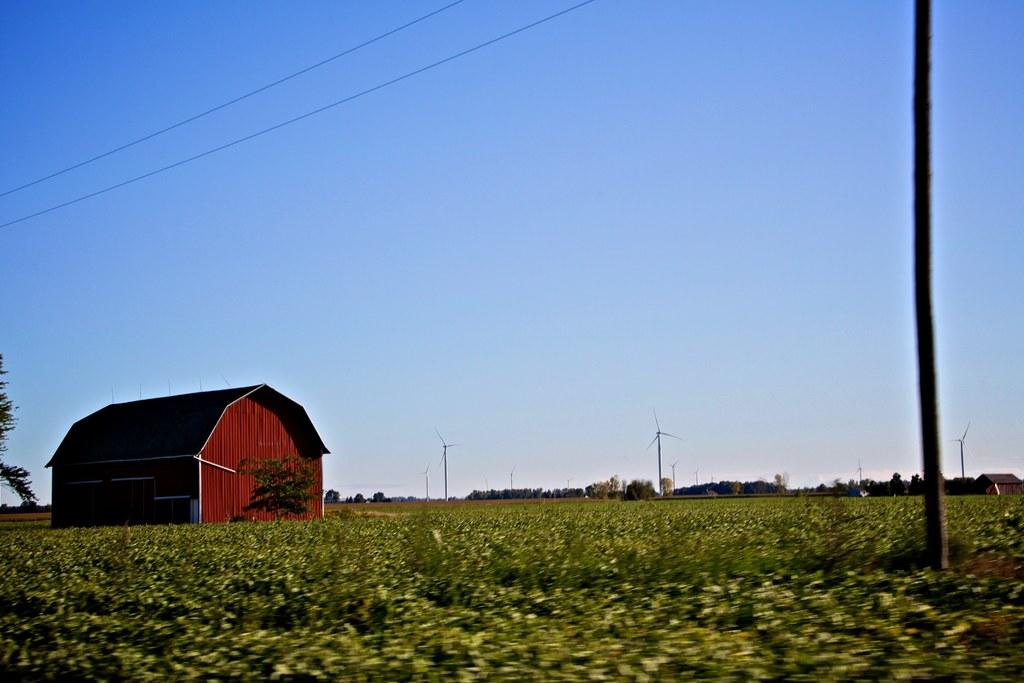What is the color of the hut in the image? The hut in the image is red. What type of vegetation is around the hut? There are green plants around the hut. What can be seen in the background of the image? There are trees in the background of the image. How does the hut manage to crush the trees in the background? The hut does not crush the trees in the background; it is a separate structure, and the trees are in the background. 